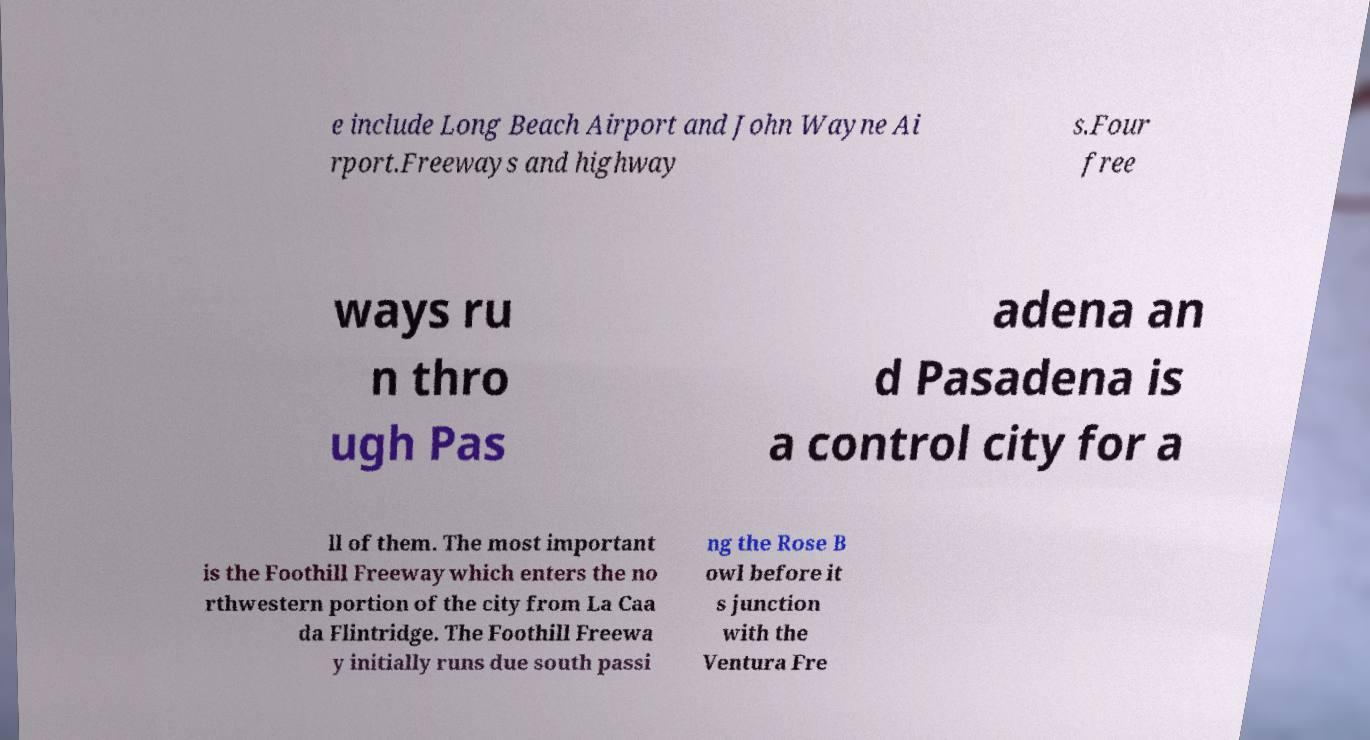Please identify and transcribe the text found in this image. e include Long Beach Airport and John Wayne Ai rport.Freeways and highway s.Four free ways ru n thro ugh Pas adena an d Pasadena is a control city for a ll of them. The most important is the Foothill Freeway which enters the no rthwestern portion of the city from La Caa da Flintridge. The Foothill Freewa y initially runs due south passi ng the Rose B owl before it s junction with the Ventura Fre 